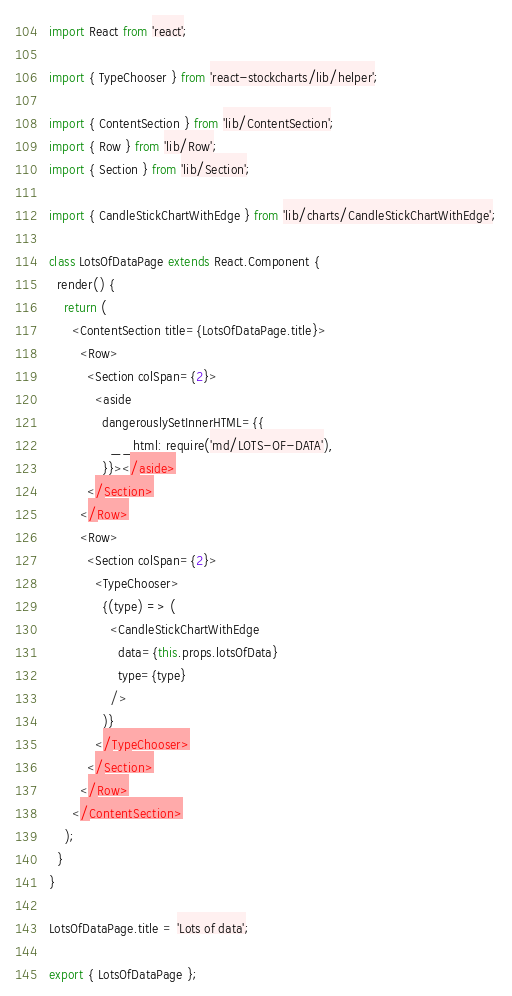<code> <loc_0><loc_0><loc_500><loc_500><_JavaScript_>import React from 'react';

import { TypeChooser } from 'react-stockcharts/lib/helper';

import { ContentSection } from 'lib/ContentSection';
import { Row } from 'lib/Row';
import { Section } from 'lib/Section';

import { CandleStickChartWithEdge } from 'lib/charts/CandleStickChartWithEdge';

class LotsOfDataPage extends React.Component {
  render() {
    return (
      <ContentSection title={LotsOfDataPage.title}>
        <Row>
          <Section colSpan={2}>
            <aside
              dangerouslySetInnerHTML={{
                __html: require('md/LOTS-OF-DATA'),
              }}></aside>
          </Section>
        </Row>
        <Row>
          <Section colSpan={2}>
            <TypeChooser>
              {(type) => (
                <CandleStickChartWithEdge
                  data={this.props.lotsOfData}
                  type={type}
                />
              )}
            </TypeChooser>
          </Section>
        </Row>
      </ContentSection>
    );
  }
}

LotsOfDataPage.title = 'Lots of data';

export { LotsOfDataPage };
</code> 